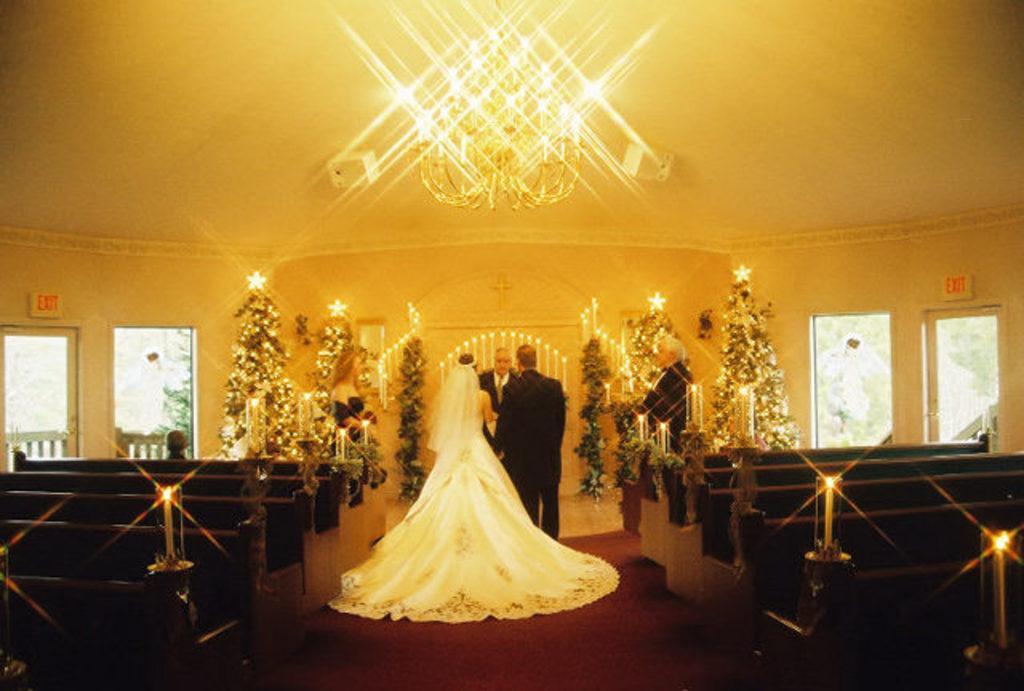Could you give a brief overview of what you see in this image? In the picture I can see a couple standing in front of a man who is wearing a suit and tie. I can see a woman on the left side and there is a man on the right side. I can see the wooden benches on the left side and the right side as well. I can see the candles on the table. I can see the trees with lighting arrangement. I can see the glass windows on the left side and the right side as well. I can see a crystal light on the roof at the top of the picture. 